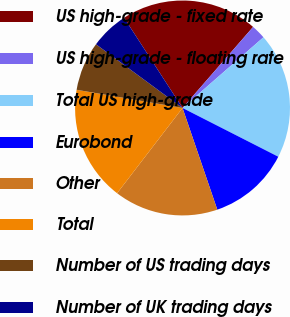<chart> <loc_0><loc_0><loc_500><loc_500><pie_chart><fcel>US high-grade - fixed rate<fcel>US high-grade - floating rate<fcel>Total US high-grade<fcel>Eurobond<fcel>Other<fcel>Total<fcel>Number of US trading days<fcel>Number of UK trading days<nl><fcel>20.55%<fcel>2.17%<fcel>18.92%<fcel>12.26%<fcel>15.66%<fcel>17.29%<fcel>7.39%<fcel>5.75%<nl></chart> 